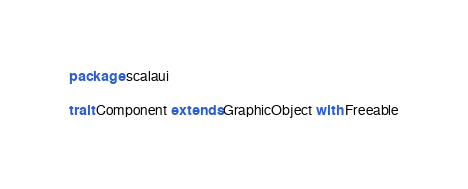<code> <loc_0><loc_0><loc_500><loc_500><_Scala_>package scalaui

trait Component extends GraphicObject with Freeable
</code> 